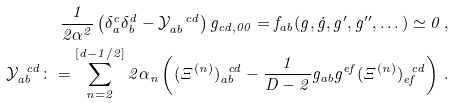<formula> <loc_0><loc_0><loc_500><loc_500>\frac { 1 } { 2 \alpha ^ { 2 } } \left ( \delta _ { a } ^ { c } \delta _ { b } ^ { d } - \mathcal { Y } _ { a b } ^ { \ \ c d } \right ) g _ { c d , 0 0 } = f _ { a b } ( g , \dot { g } , g ^ { \prime } , g ^ { \prime \prime } , \dots ) \simeq 0 \, , \\ \mathcal { Y } _ { a b } ^ { \ \ c d } \colon = \sum _ { n = 2 } ^ { [ d - 1 / 2 ] } 2 \alpha _ { n } \left ( ( \Xi ^ { ( n ) } ) _ { a b } ^ { \ \ c d } - \frac { 1 } { D - 2 } g _ { a b } g ^ { e f } ( \Xi ^ { ( n ) } ) _ { e f } ^ { \ \ c d } \right ) \, .</formula> 